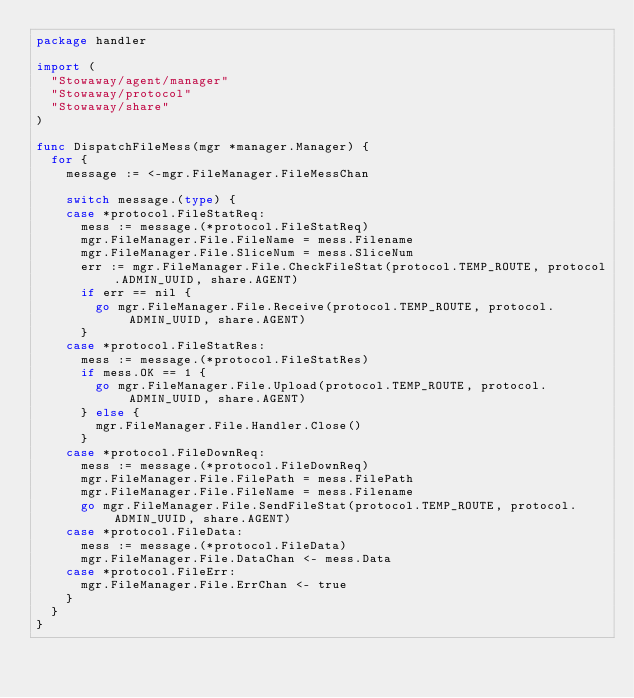<code> <loc_0><loc_0><loc_500><loc_500><_Go_>package handler

import (
	"Stowaway/agent/manager"
	"Stowaway/protocol"
	"Stowaway/share"
)

func DispatchFileMess(mgr *manager.Manager) {
	for {
		message := <-mgr.FileManager.FileMessChan

		switch message.(type) {
		case *protocol.FileStatReq:
			mess := message.(*protocol.FileStatReq)
			mgr.FileManager.File.FileName = mess.Filename
			mgr.FileManager.File.SliceNum = mess.SliceNum
			err := mgr.FileManager.File.CheckFileStat(protocol.TEMP_ROUTE, protocol.ADMIN_UUID, share.AGENT)
			if err == nil {
				go mgr.FileManager.File.Receive(protocol.TEMP_ROUTE, protocol.ADMIN_UUID, share.AGENT)
			}
		case *protocol.FileStatRes:
			mess := message.(*protocol.FileStatRes)
			if mess.OK == 1 {
				go mgr.FileManager.File.Upload(protocol.TEMP_ROUTE, protocol.ADMIN_UUID, share.AGENT)
			} else {
				mgr.FileManager.File.Handler.Close()
			}
		case *protocol.FileDownReq:
			mess := message.(*protocol.FileDownReq)
			mgr.FileManager.File.FilePath = mess.FilePath
			mgr.FileManager.File.FileName = mess.Filename
			go mgr.FileManager.File.SendFileStat(protocol.TEMP_ROUTE, protocol.ADMIN_UUID, share.AGENT)
		case *protocol.FileData:
			mess := message.(*protocol.FileData)
			mgr.FileManager.File.DataChan <- mess.Data
		case *protocol.FileErr:
			mgr.FileManager.File.ErrChan <- true
		}
	}
}
</code> 